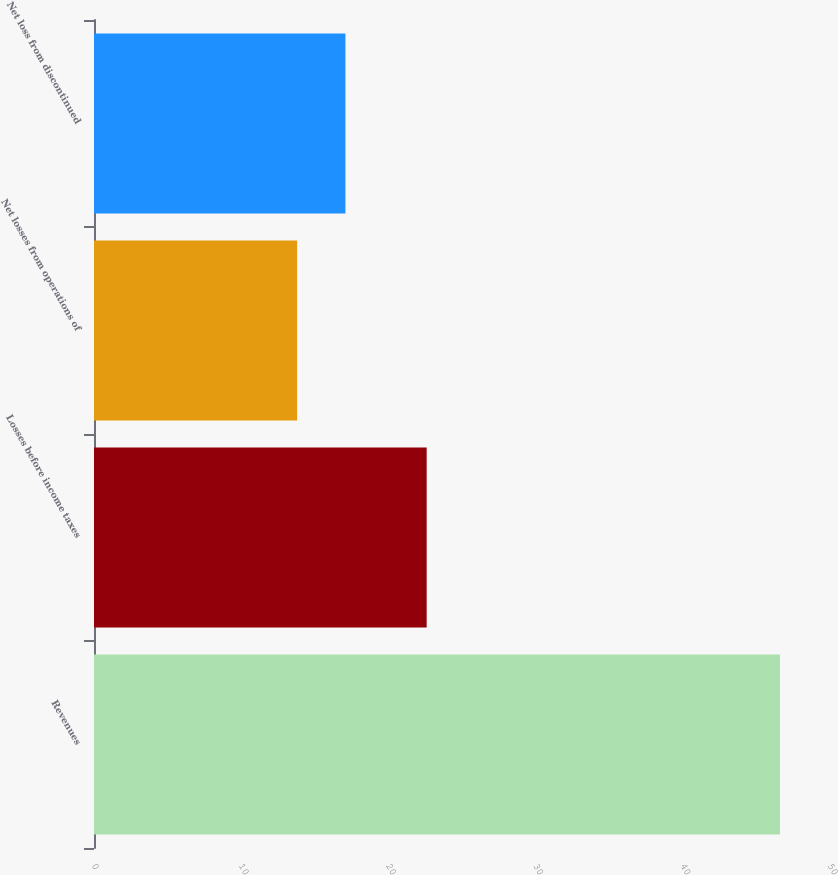<chart> <loc_0><loc_0><loc_500><loc_500><bar_chart><fcel>Revenues<fcel>Losses before income taxes<fcel>Net losses from operations of<fcel>Net loss from discontinued<nl><fcel>46.6<fcel>22.6<fcel>13.8<fcel>17.08<nl></chart> 